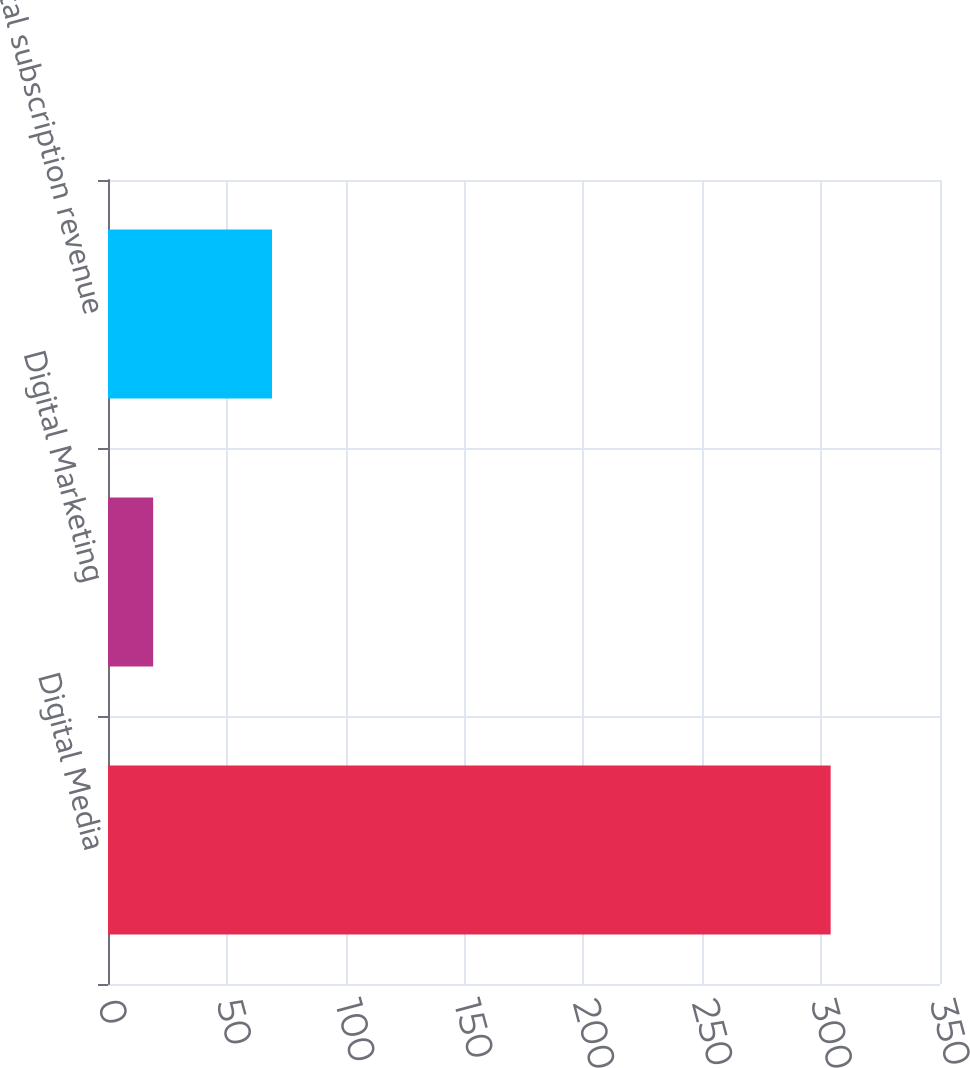<chart> <loc_0><loc_0><loc_500><loc_500><bar_chart><fcel>Digital Media<fcel>Digital Marketing<fcel>Total subscription revenue<nl><fcel>304<fcel>19<fcel>69<nl></chart> 